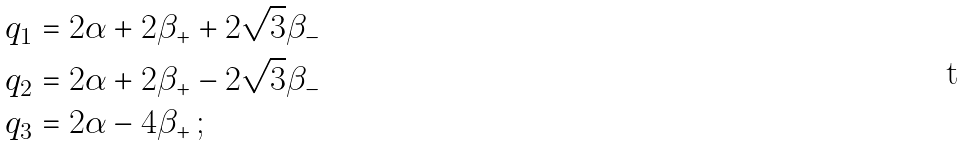Convert formula to latex. <formula><loc_0><loc_0><loc_500><loc_500>q _ { 1 } & = 2 \alpha + 2 \beta _ { + } + 2 \sqrt { 3 } \beta _ { - } \\ q _ { 2 } & = 2 \alpha + 2 \beta _ { + } - 2 \sqrt { 3 } \beta _ { - } \\ q _ { 3 } & = 2 \alpha - 4 \beta _ { + } \, ;</formula> 